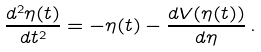<formula> <loc_0><loc_0><loc_500><loc_500>\frac { d ^ { 2 } \eta ( t ) } { d t ^ { 2 } } = - \eta ( t ) - \frac { d V ( \eta ( t ) ) } { d \eta } \, .</formula> 